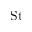<formula> <loc_0><loc_0><loc_500><loc_500>S t</formula> 